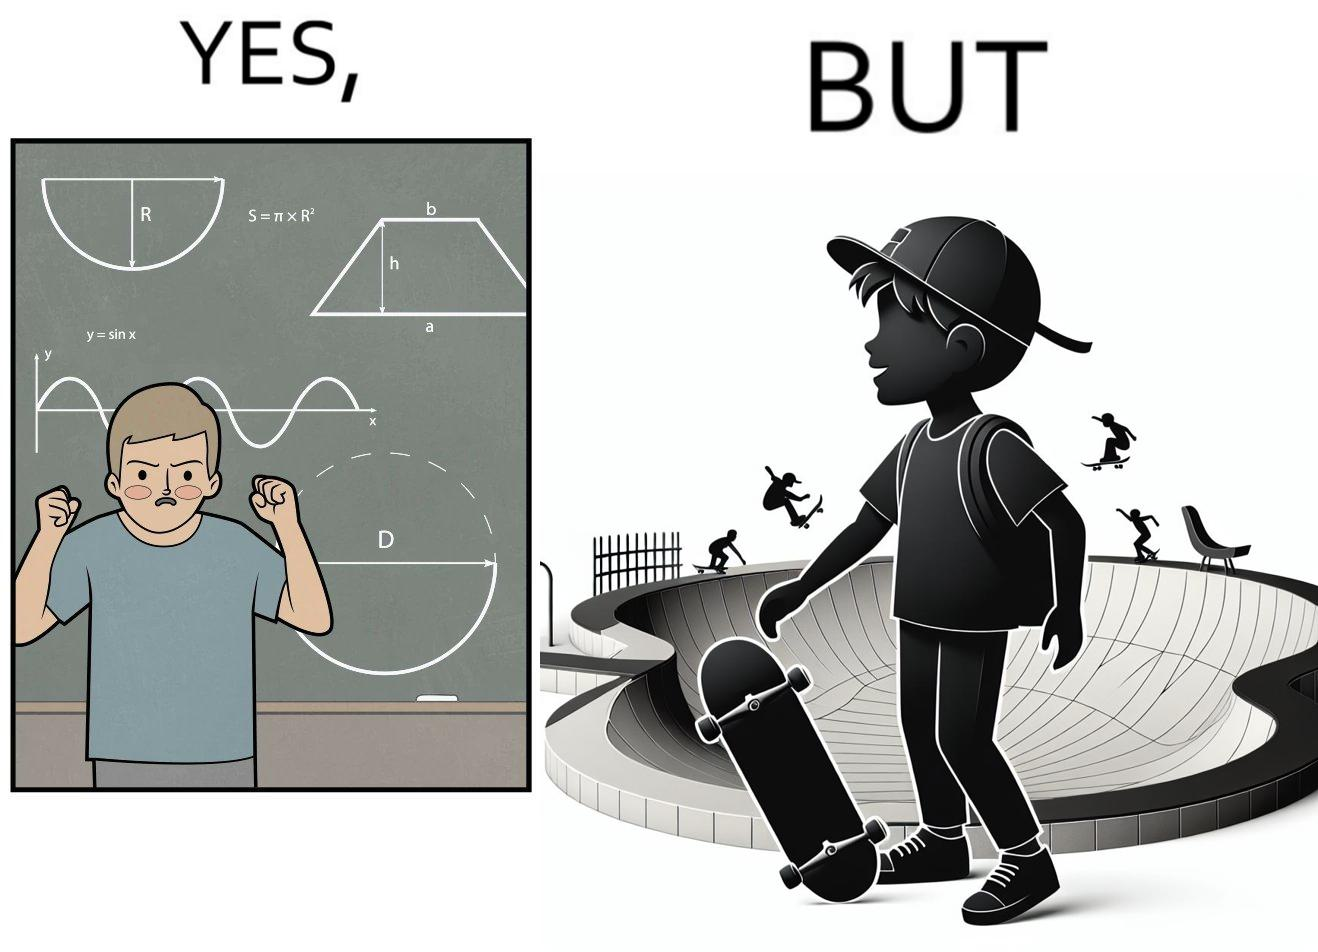Would you classify this image as satirical? Yes, this image is satirical. 